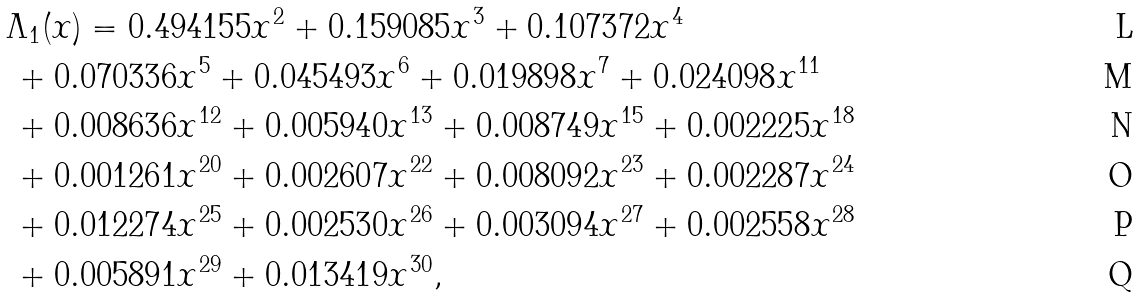<formula> <loc_0><loc_0><loc_500><loc_500>& \Lambda _ { 1 } ( x ) = 0 . 4 9 4 1 5 5 x ^ { 2 } + 0 . 1 5 9 0 8 5 x ^ { 3 } + 0 . 1 0 7 3 7 2 x ^ { 4 } \\ & \, + 0 . 0 7 0 3 3 6 x ^ { 5 } + 0 . 0 4 5 4 9 3 x ^ { 6 } + 0 . 0 1 9 8 9 8 x ^ { 7 } + 0 . 0 2 4 0 9 8 x ^ { 1 1 } \\ & \, + 0 . 0 0 8 6 3 6 x ^ { 1 2 } + 0 . 0 0 5 9 4 0 x ^ { 1 3 } + 0 . 0 0 8 7 4 9 x ^ { 1 5 } + 0 . 0 0 2 2 2 5 x ^ { 1 8 } \\ & \, + 0 . 0 0 1 2 6 1 x ^ { 2 0 } + 0 . 0 0 2 6 0 7 x ^ { 2 2 } + 0 . 0 0 8 0 9 2 x ^ { 2 3 } + 0 . 0 0 2 2 8 7 x ^ { 2 4 } \\ & \, + 0 . 0 1 2 2 7 4 x ^ { 2 5 } + 0 . 0 0 2 5 3 0 x ^ { 2 6 } + 0 . 0 0 3 0 9 4 x ^ { 2 7 } + 0 . 0 0 2 5 5 8 x ^ { 2 8 } \\ & \, + 0 . 0 0 5 8 9 1 x ^ { 2 9 } + 0 . 0 1 3 4 1 9 x ^ { 3 0 } ,</formula> 